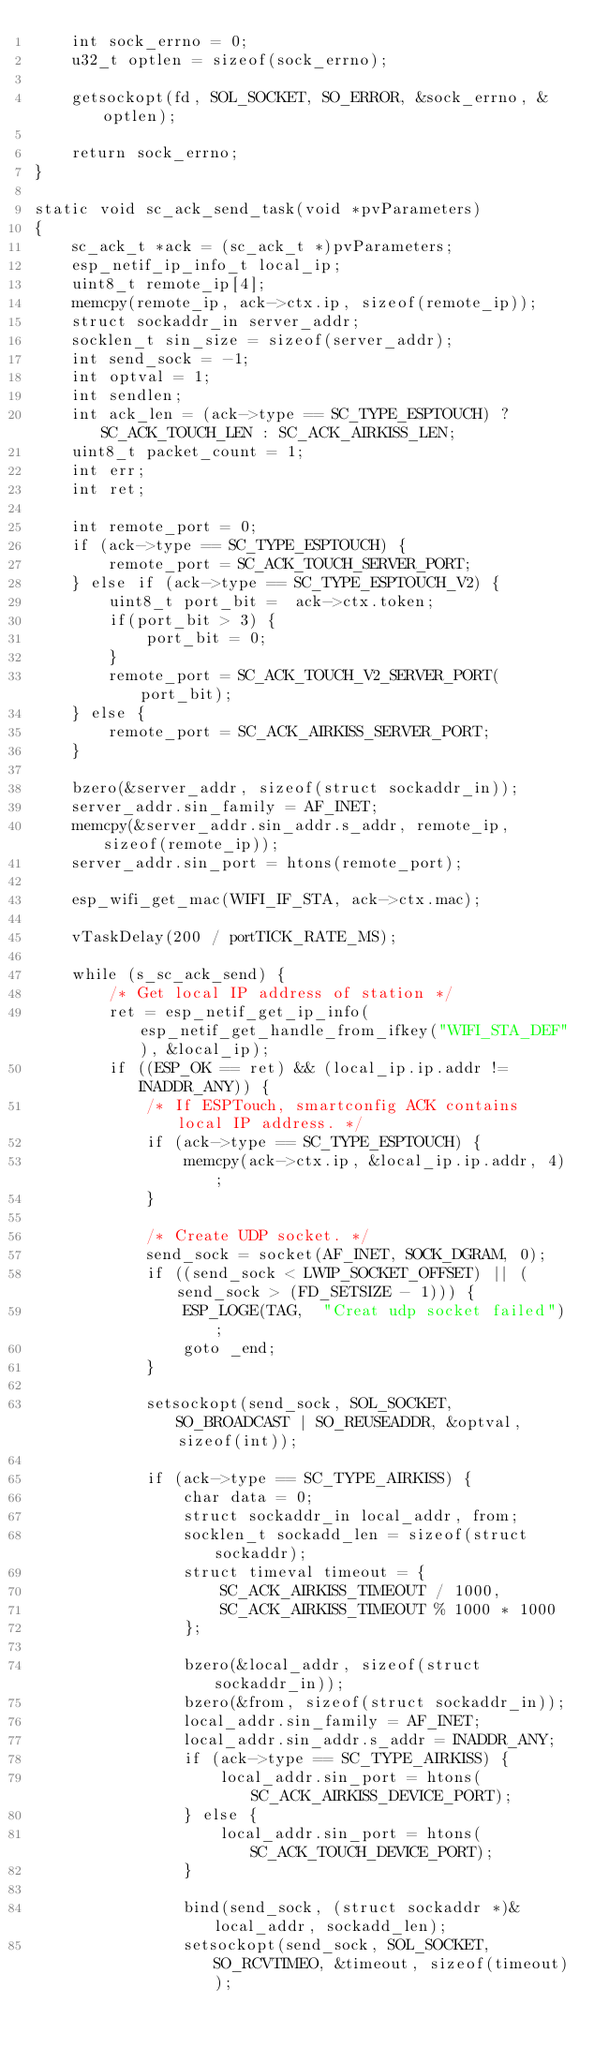<code> <loc_0><loc_0><loc_500><loc_500><_C_>    int sock_errno = 0;
    u32_t optlen = sizeof(sock_errno);

    getsockopt(fd, SOL_SOCKET, SO_ERROR, &sock_errno, &optlen);

    return sock_errno;
}

static void sc_ack_send_task(void *pvParameters)
{
    sc_ack_t *ack = (sc_ack_t *)pvParameters;
    esp_netif_ip_info_t local_ip;
    uint8_t remote_ip[4];
    memcpy(remote_ip, ack->ctx.ip, sizeof(remote_ip));
    struct sockaddr_in server_addr;
    socklen_t sin_size = sizeof(server_addr);
    int send_sock = -1;
    int optval = 1;
    int sendlen;
    int ack_len = (ack->type == SC_TYPE_ESPTOUCH) ? SC_ACK_TOUCH_LEN : SC_ACK_AIRKISS_LEN;
    uint8_t packet_count = 1;
    int err;
    int ret;

    int remote_port = 0;
    if (ack->type == SC_TYPE_ESPTOUCH) {
        remote_port = SC_ACK_TOUCH_SERVER_PORT;
    } else if (ack->type == SC_TYPE_ESPTOUCH_V2) {
        uint8_t port_bit =  ack->ctx.token;
        if(port_bit > 3) {
            port_bit = 0;
        }
        remote_port = SC_ACK_TOUCH_V2_SERVER_PORT(port_bit);
    } else {
        remote_port = SC_ACK_AIRKISS_SERVER_PORT;
    }

    bzero(&server_addr, sizeof(struct sockaddr_in));
    server_addr.sin_family = AF_INET;
    memcpy(&server_addr.sin_addr.s_addr, remote_ip, sizeof(remote_ip));
    server_addr.sin_port = htons(remote_port);

    esp_wifi_get_mac(WIFI_IF_STA, ack->ctx.mac);

    vTaskDelay(200 / portTICK_RATE_MS);

    while (s_sc_ack_send) {
        /* Get local IP address of station */
        ret = esp_netif_get_ip_info(esp_netif_get_handle_from_ifkey("WIFI_STA_DEF"), &local_ip);
        if ((ESP_OK == ret) && (local_ip.ip.addr != INADDR_ANY)) {
            /* If ESPTouch, smartconfig ACK contains local IP address. */
            if (ack->type == SC_TYPE_ESPTOUCH) {
                memcpy(ack->ctx.ip, &local_ip.ip.addr, 4);
            }

            /* Create UDP socket. */
            send_sock = socket(AF_INET, SOCK_DGRAM, 0);
            if ((send_sock < LWIP_SOCKET_OFFSET) || (send_sock > (FD_SETSIZE - 1))) {
                ESP_LOGE(TAG,  "Creat udp socket failed");
                goto _end;
            }

            setsockopt(send_sock, SOL_SOCKET, SO_BROADCAST | SO_REUSEADDR, &optval, sizeof(int));

            if (ack->type == SC_TYPE_AIRKISS) {
                char data = 0;
                struct sockaddr_in local_addr, from;
                socklen_t sockadd_len = sizeof(struct sockaddr);
                struct timeval timeout = {
                    SC_ACK_AIRKISS_TIMEOUT / 1000,
                    SC_ACK_AIRKISS_TIMEOUT % 1000 * 1000
                };

                bzero(&local_addr, sizeof(struct sockaddr_in));
                bzero(&from, sizeof(struct sockaddr_in));
                local_addr.sin_family = AF_INET;
                local_addr.sin_addr.s_addr = INADDR_ANY;
                if (ack->type == SC_TYPE_AIRKISS) {
                    local_addr.sin_port = htons(SC_ACK_AIRKISS_DEVICE_PORT);
                } else {
                    local_addr.sin_port = htons(SC_ACK_TOUCH_DEVICE_PORT);
                }

                bind(send_sock, (struct sockaddr *)&local_addr, sockadd_len);
                setsockopt(send_sock, SOL_SOCKET, SO_RCVTIMEO, &timeout, sizeof(timeout));
</code> 